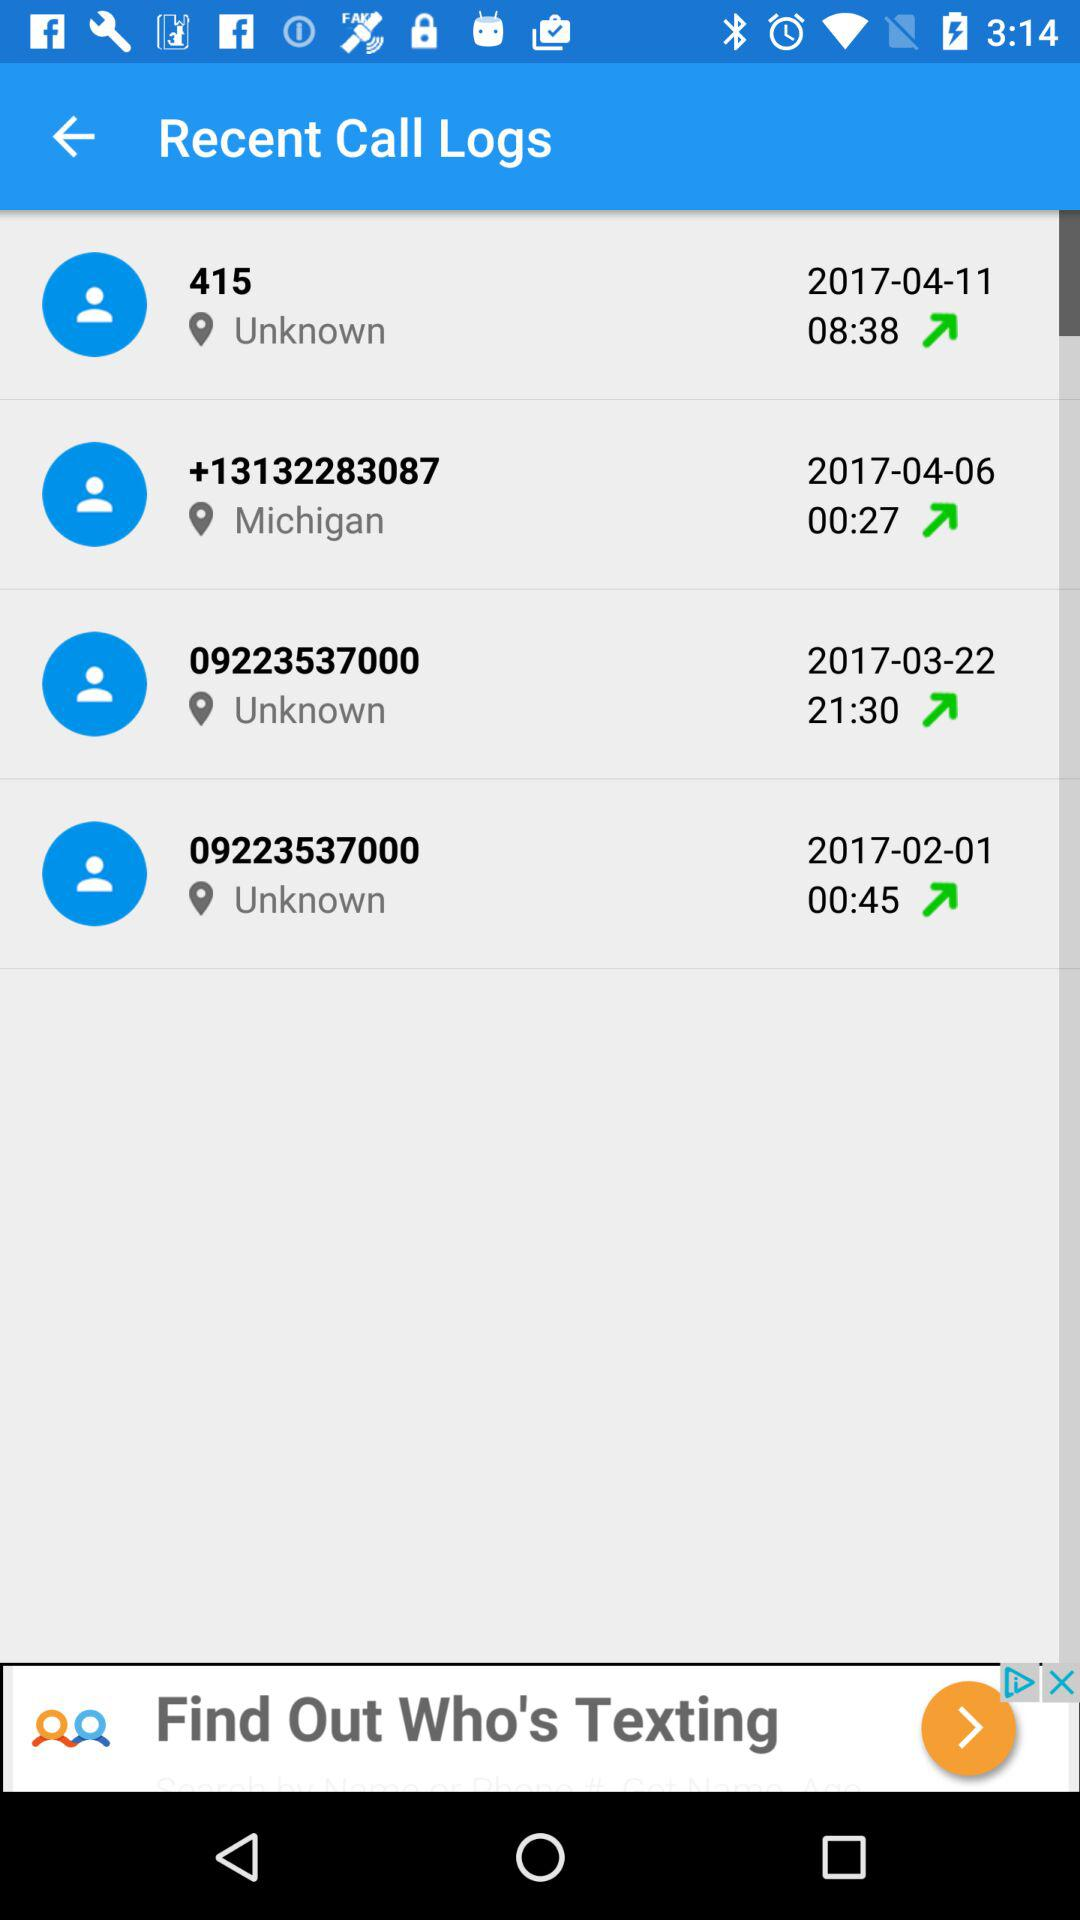Which number was called on 2017-03-22? The number that was called on March 22, 2017 is 09223537000. 